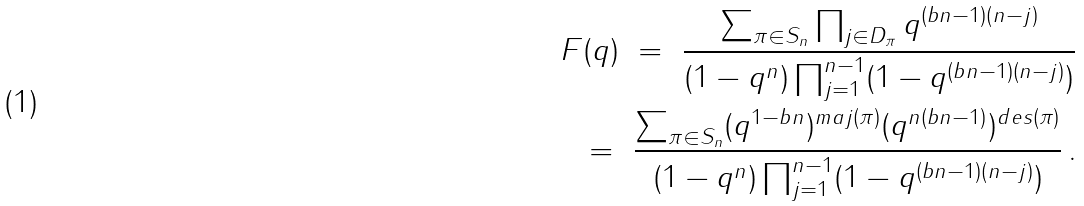Convert formula to latex. <formula><loc_0><loc_0><loc_500><loc_500>F ( q ) \ = \ \frac { \sum _ { \pi \in S _ { n } } \prod _ { j \in D _ { \pi } } q ^ { ( b n - 1 ) ( n - j ) } } { ( 1 - q ^ { n } ) \prod _ { j = 1 } ^ { n - 1 } ( 1 - q ^ { ( b n - 1 ) ( n - j ) } ) } \\ \ = \ \frac { \sum _ { \pi \in S _ { n } } ( q ^ { 1 - b n } ) ^ { m a j ( \pi ) } ( q ^ { n ( b n - 1 ) } ) ^ { d e s ( \pi ) } } { ( 1 - q ^ { n } ) \prod _ { j = 1 } ^ { n - 1 } ( 1 - q ^ { ( b n - 1 ) ( n - j ) } ) } \, .</formula> 